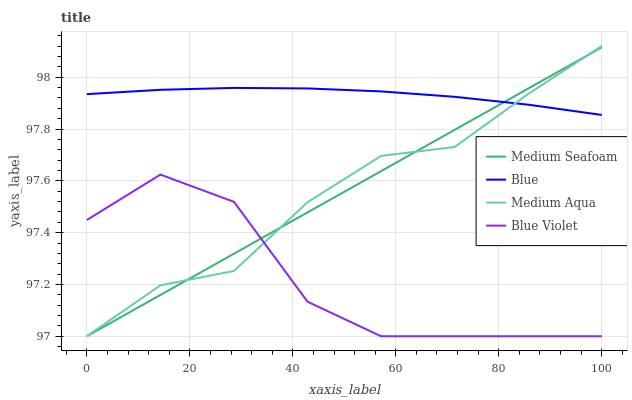Does Blue Violet have the minimum area under the curve?
Answer yes or no. Yes. Does Blue have the maximum area under the curve?
Answer yes or no. Yes. Does Medium Aqua have the minimum area under the curve?
Answer yes or no. No. Does Medium Aqua have the maximum area under the curve?
Answer yes or no. No. Is Medium Seafoam the smoothest?
Answer yes or no. Yes. Is Blue Violet the roughest?
Answer yes or no. Yes. Is Medium Aqua the smoothest?
Answer yes or no. No. Is Medium Aqua the roughest?
Answer yes or no. No. Does Medium Aqua have the lowest value?
Answer yes or no. Yes. Does Medium Aqua have the highest value?
Answer yes or no. Yes. Does Medium Seafoam have the highest value?
Answer yes or no. No. Is Blue Violet less than Blue?
Answer yes or no. Yes. Is Blue greater than Blue Violet?
Answer yes or no. Yes. Does Medium Aqua intersect Medium Seafoam?
Answer yes or no. Yes. Is Medium Aqua less than Medium Seafoam?
Answer yes or no. No. Is Medium Aqua greater than Medium Seafoam?
Answer yes or no. No. Does Blue Violet intersect Blue?
Answer yes or no. No. 